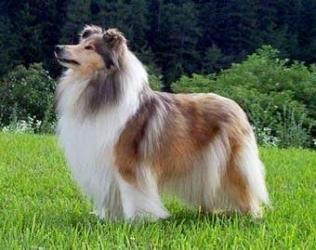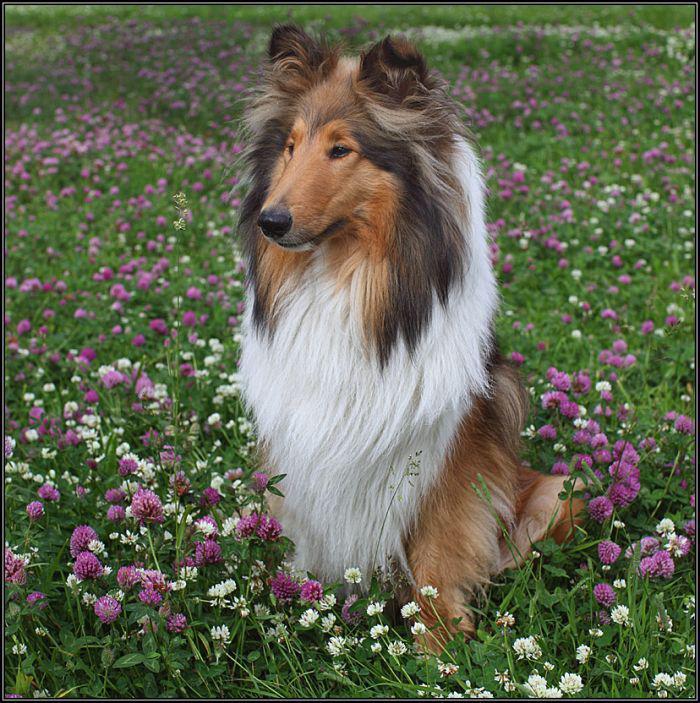The first image is the image on the left, the second image is the image on the right. Analyze the images presented: Is the assertion "One of the dogs is standing in the grass." valid? Answer yes or no. Yes. The first image is the image on the left, the second image is the image on the right. Given the left and right images, does the statement "An adult collie dog poses in a scene with vibrant flowers." hold true? Answer yes or no. Yes. 